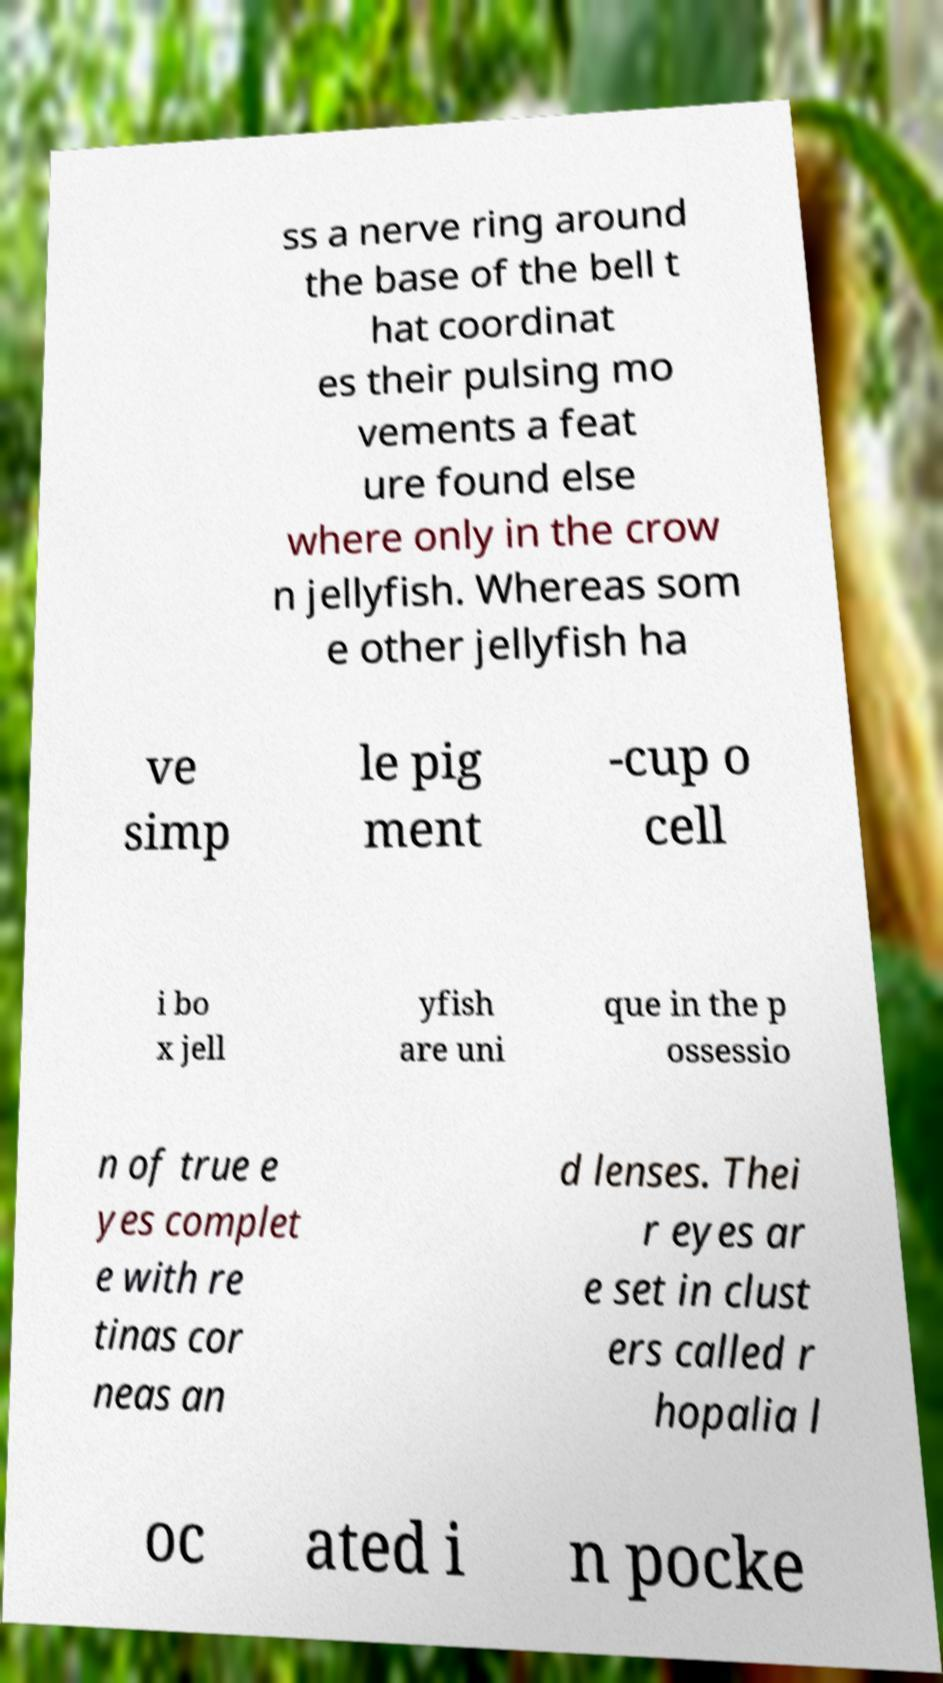I need the written content from this picture converted into text. Can you do that? ss a nerve ring around the base of the bell t hat coordinat es their pulsing mo vements a feat ure found else where only in the crow n jellyfish. Whereas som e other jellyfish ha ve simp le pig ment -cup o cell i bo x jell yfish are uni que in the p ossessio n of true e yes complet e with re tinas cor neas an d lenses. Thei r eyes ar e set in clust ers called r hopalia l oc ated i n pocke 